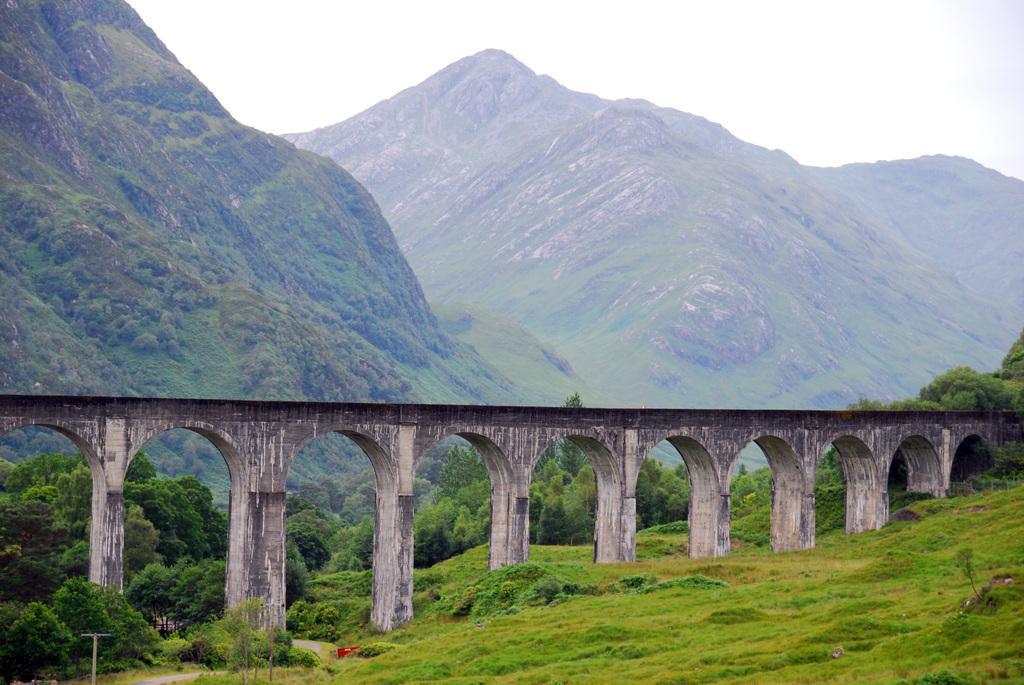Can you describe this image briefly? In this image in the center there is one bridge, at the bottom there is grass and some trees and in the background there are some mountains. 